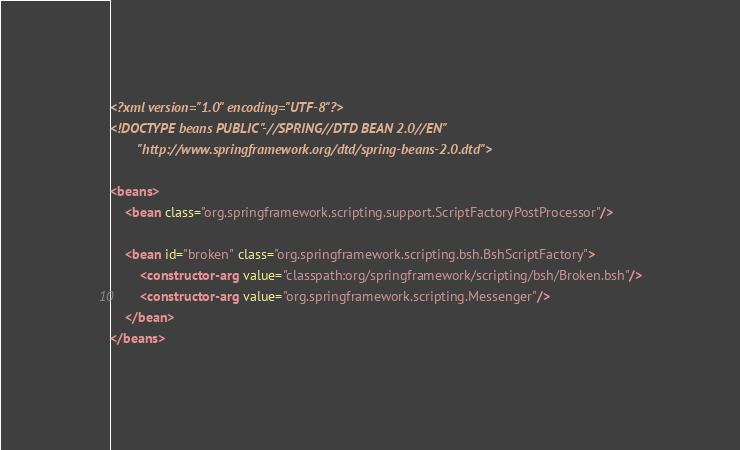Convert code to text. <code><loc_0><loc_0><loc_500><loc_500><_XML_><?xml version="1.0" encoding="UTF-8"?>
<!DOCTYPE beans PUBLIC "-//SPRING//DTD BEAN 2.0//EN"
		"http://www.springframework.org/dtd/spring-beans-2.0.dtd">

<beans>
	<bean class="org.springframework.scripting.support.ScriptFactoryPostProcessor"/>

	<bean id="broken" class="org.springframework.scripting.bsh.BshScriptFactory">
		<constructor-arg value="classpath:org/springframework/scripting/bsh/Broken.bsh"/>
		<constructor-arg value="org.springframework.scripting.Messenger"/>
	</bean>
</beans></code> 